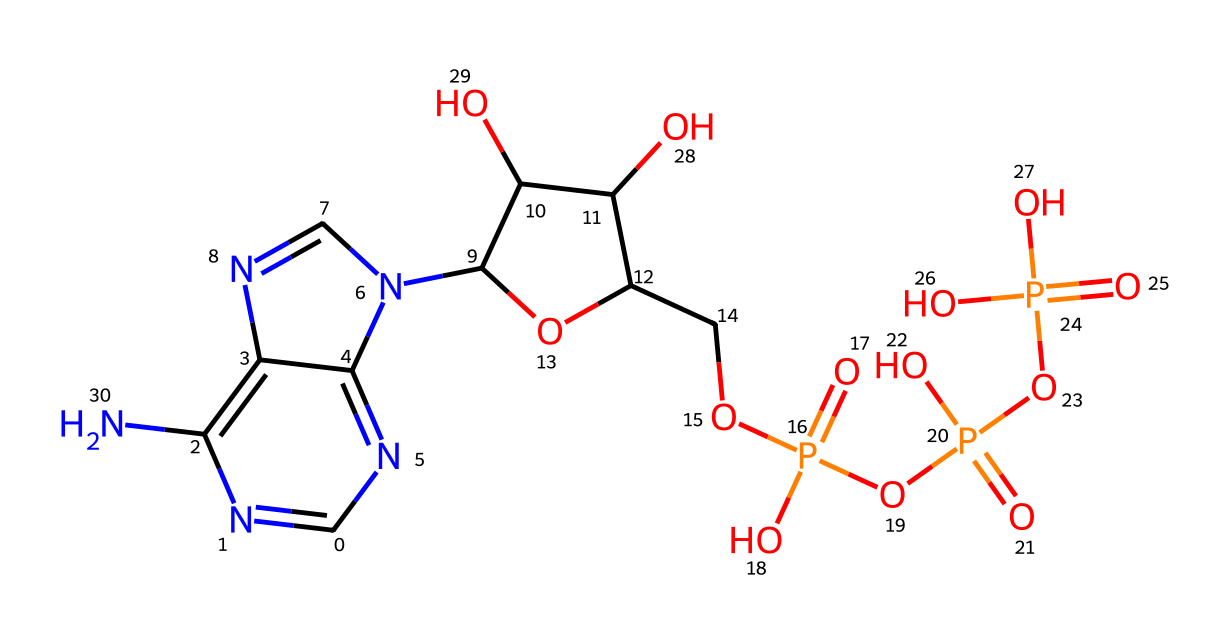What is the number of phosphorus atoms in ATP? The chemical structure contains three instances of the phosphorus atom represented by the P in the structure's phosphate groups. By identifying and counting each P present, we confirm the total.
Answer: three How many total oxygen atoms are present in ATP? By examining the chemical structure, we can visually identify and count each oxygen atom (O). Each phosphate group typically contributes four oxygen atoms, and in this structure, there are five oxygen atoms displayed visually, thus totaling them gives the final count.
Answer: ten What type of molecule is ATP primarily classified as? ATP, based on its structure, is primarily classified as a nucleotide, which is evident from its composition that includes a nitrogenous base, a sugar unit, and phosphate groups.
Answer: nucleotide Which part of the ATP structure provides energy for muscle contractions? The energy is primarily released from the high-energy phosphate bonds located between the phosphate groups in the molecule. When these are cleaved, they provide the energy needed for muscle contractions.
Answer: phosphate bonds What does the "triphosphate" in adenosine triphosphate indicate? The term "triphosphate" refers to the presence of three phosphate groups in the ATP molecule, which are critical for its role in energy transfer within cells.
Answer: three phosphate groups Are there any nitrogen atoms present in ATP? If so, how many? Yes, the structure shows the presence of four nitrogen atoms, indicated by the N symbols present in the nucleotide portion of ATP. Counting reveals the total number.
Answer: four nitrogen atoms 